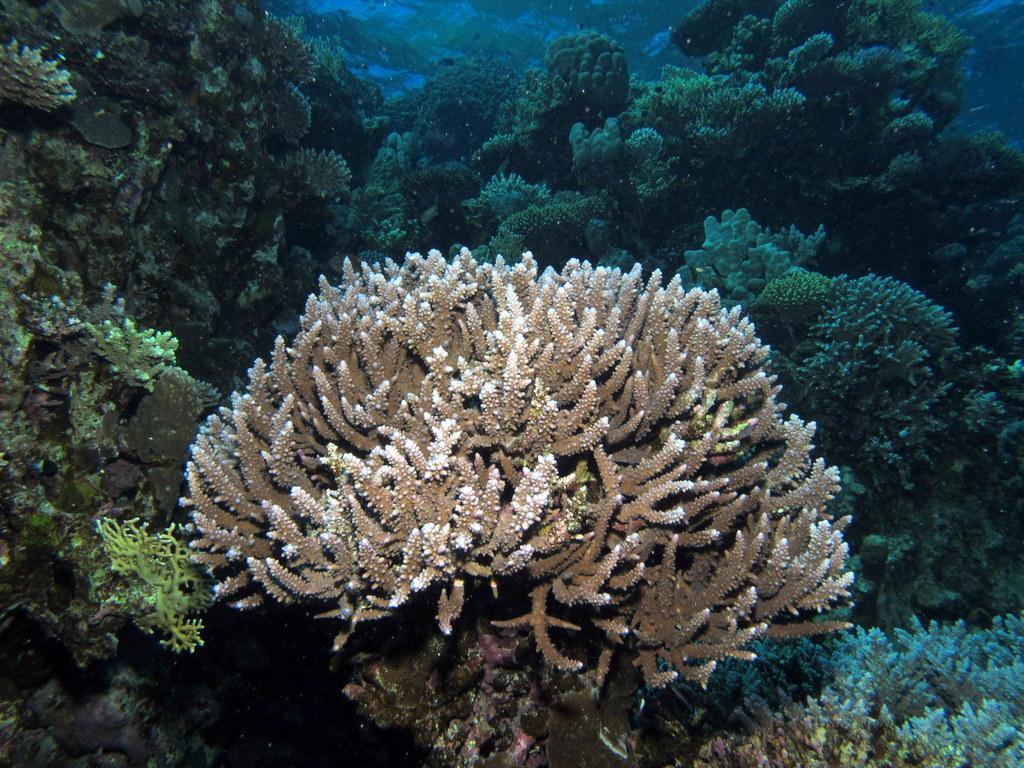Can you describe this image briefly? In this image we can see the beauty of the underwater in the sea. There are so many bushes in the sea. 